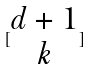<formula> <loc_0><loc_0><loc_500><loc_500>[ \begin{matrix} d + 1 \\ k \end{matrix} ]</formula> 